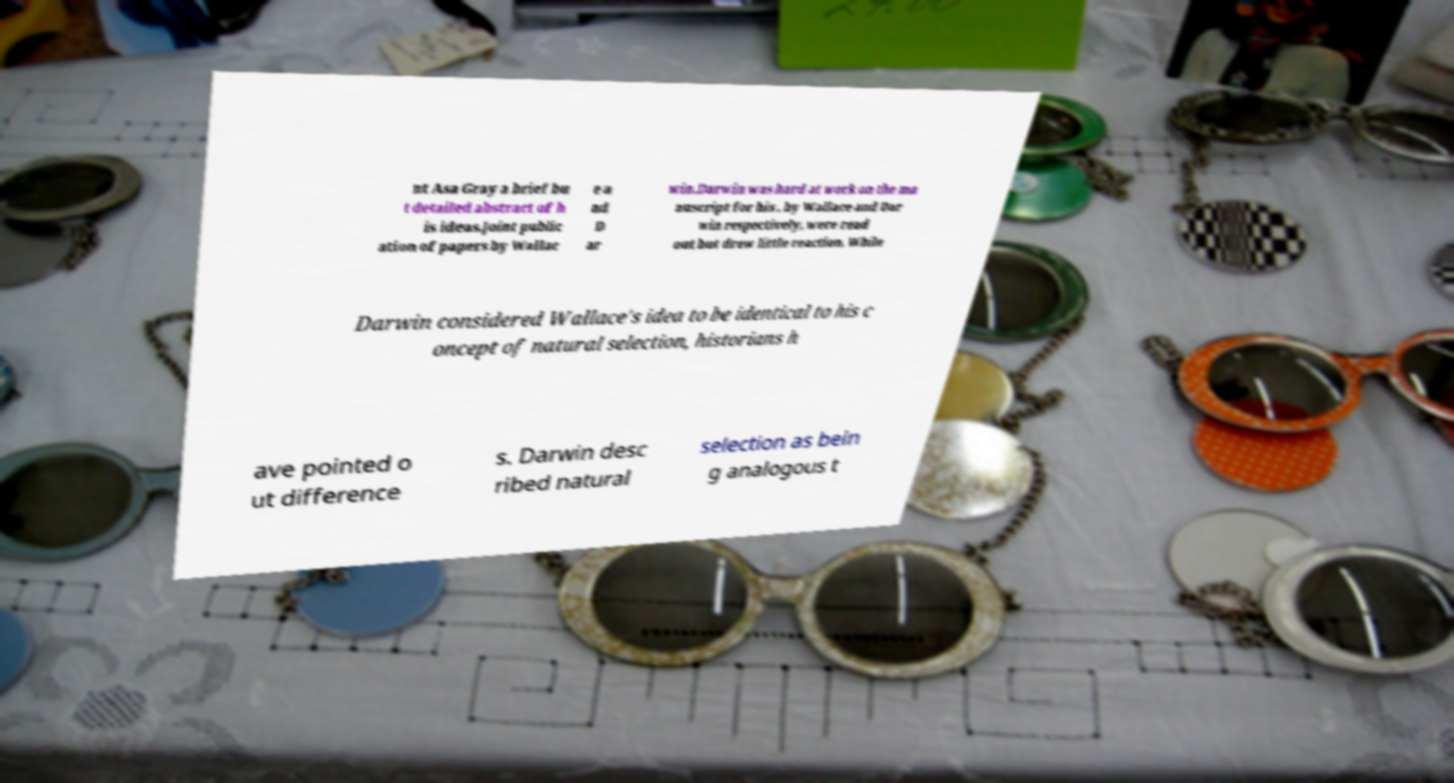For documentation purposes, I need the text within this image transcribed. Could you provide that? nt Asa Gray a brief bu t detailed abstract of h is ideas.Joint public ation of papers by Wallac e a nd D ar win.Darwin was hard at work on the ma nuscript for his , by Wallace and Dar win respectively, were read out but drew little reaction. While Darwin considered Wallace's idea to be identical to his c oncept of natural selection, historians h ave pointed o ut difference s. Darwin desc ribed natural selection as bein g analogous t 